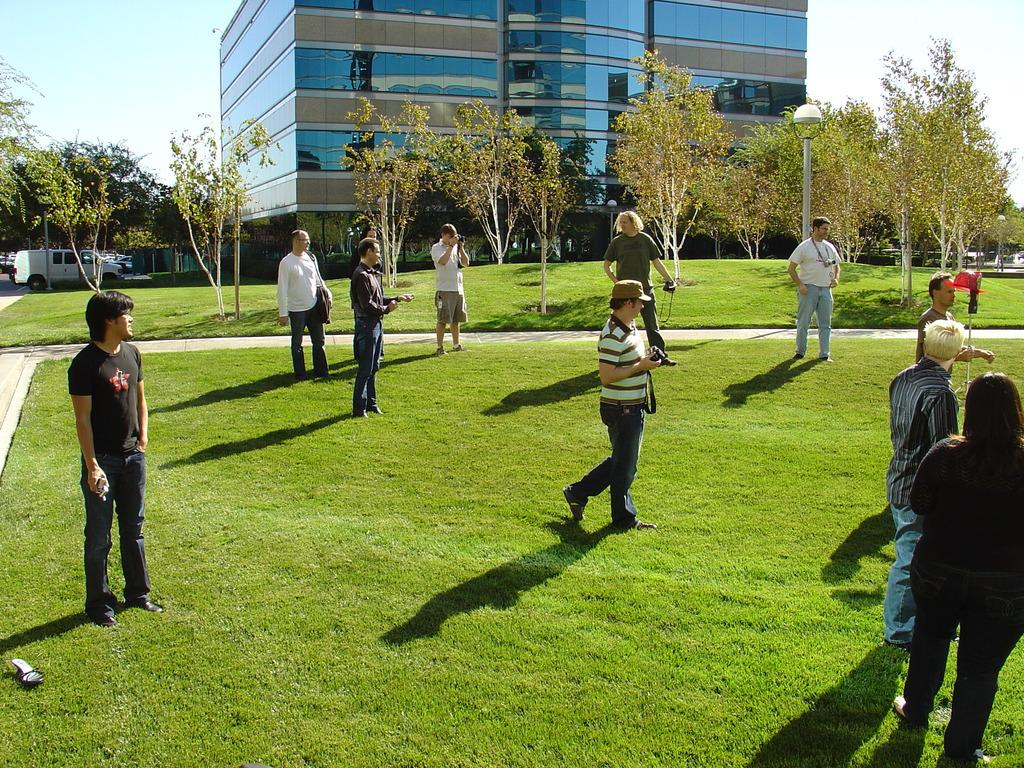What is the surface that the people are standing on in the image? The people are standing on the grass ground. What type of natural elements can be seen in the image? There are trees in the image. What type of structure is present in the image? There is a building in the image. What type of transportation is visible in the image? There is a vehicle on the road in the image. How many screws are visible on the building in the image? There are no screws visible on the building in the image. What type of boot is being worn by the people standing on the grass ground? There is no mention of boots or footwear in the image. 